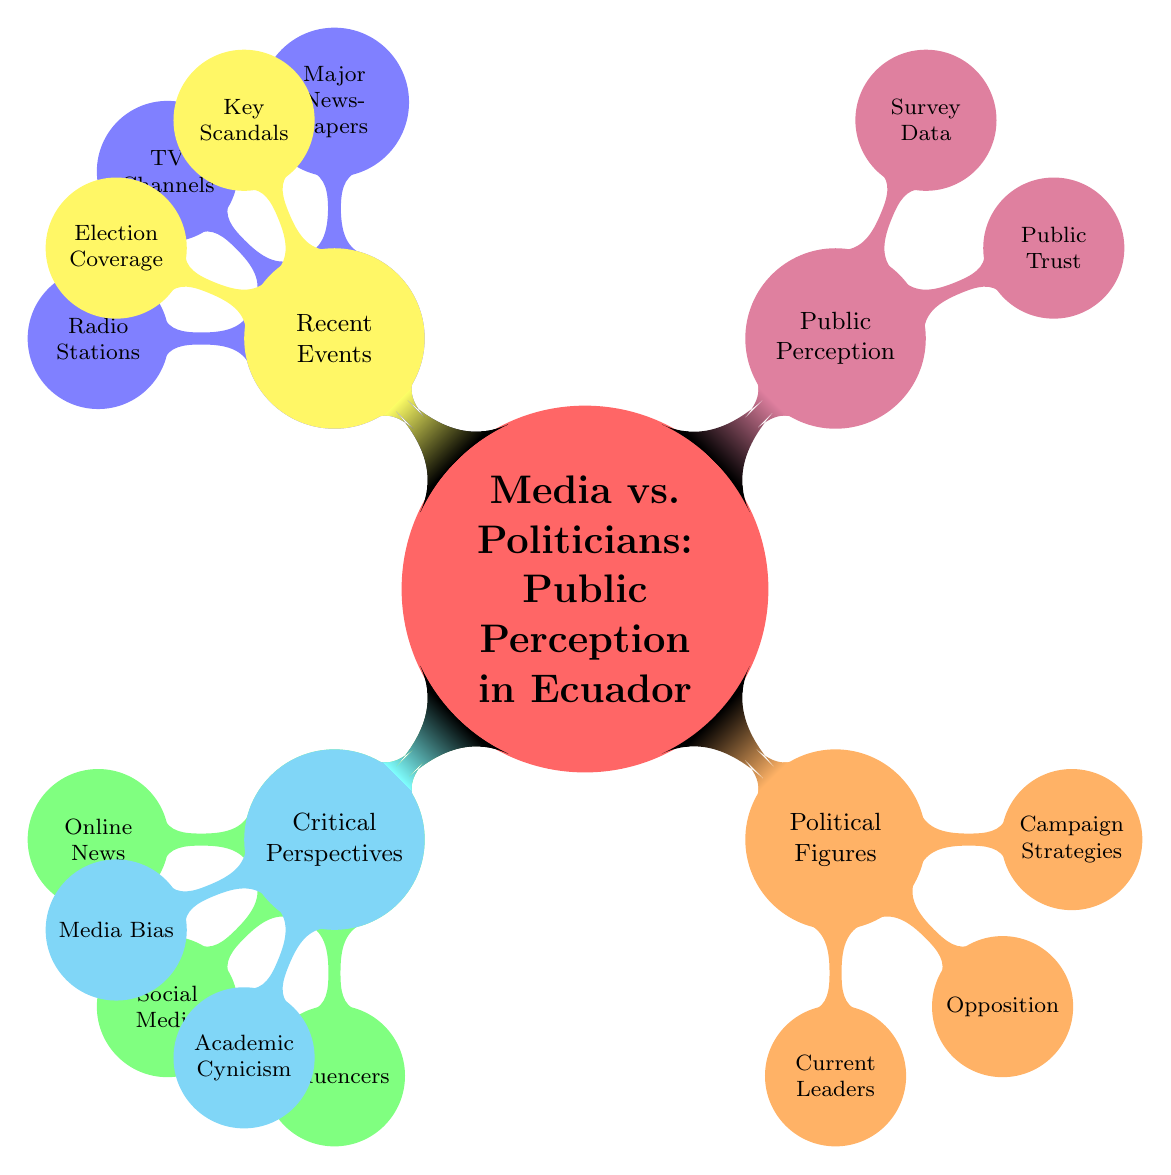What are the major newspapers listed in the diagram? By examining the node under "Mainstream Media," two specific examples are provided: "El Universo" and "El Comercio."
Answer: El Universo, El Comercio Which political figure is listed as a current leader? In the "Political Figures" section under "Current Leaders," "Guillermo Lasso" is identified as one of the leaders currently in power.
Answer: Guillermo Lasso How many nodes are in the "Digital Media" section? The "Digital Media" section has three children nodes: "Online News Portals," "Social Media Platforms," and "Influencers," indicating three specific types of digital media.
Answer: 3 What is a key scandal mentioned in the diagram? Under the "Recent Events" section, one key scandal mentioned includes "INA Papers," highlighting a significant event affecting public perception.
Answer: INA Papers What influences public trust in politicians according to the diagram? The diagram notes that there is "High distrust in politicians," pointing out a significant issue regarding public trust towards political figures.
Answer: High distrust in politicians What does the "Critical Perspectives" section address? This section discusses two specific topics: "Media Bias" and "Cynicism in Academia," offering insights into broader issues affecting media and politics in Ecuador.
Answer: Media Bias, Cynicism in Academia Which social media platforms are identified in the diagram? The "Digital Media" section lists "Facebook" and "Twitter" as the main social media platforms, showing the digital landscape influencing public perception.
Answer: Facebook, Twitter What are the two election events referred to in the diagram? The "Recent Events" section mentions "2021 Presidential Election" and "2017 Referendum," two significant electoral events shaping political dynamics in Ecuador.
Answer: 2021 Presidential Election, 2017 Referendum 